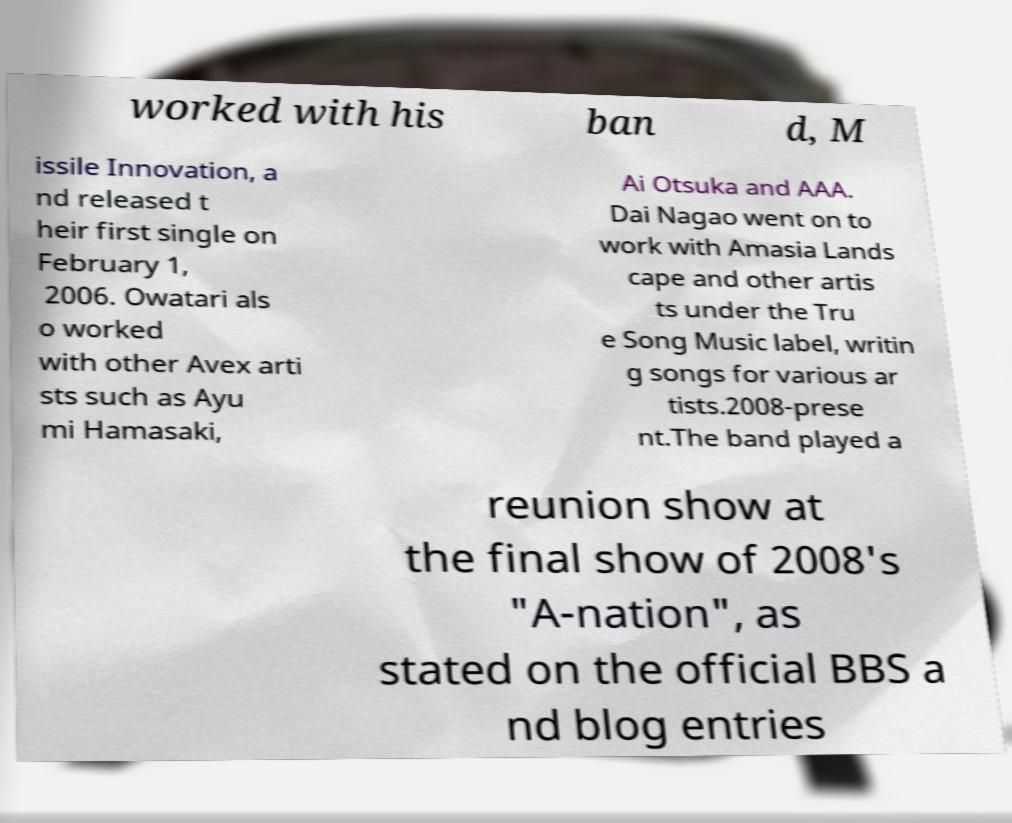Could you assist in decoding the text presented in this image and type it out clearly? worked with his ban d, M issile Innovation, a nd released t heir first single on February 1, 2006. Owatari als o worked with other Avex arti sts such as Ayu mi Hamasaki, Ai Otsuka and AAA. Dai Nagao went on to work with Amasia Lands cape and other artis ts under the Tru e Song Music label, writin g songs for various ar tists.2008-prese nt.The band played a reunion show at the final show of 2008's "A-nation", as stated on the official BBS a nd blog entries 